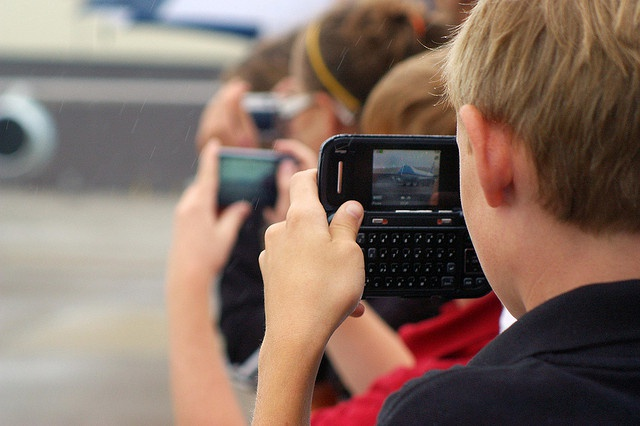Describe the objects in this image and their specific colors. I can see people in beige, black, brown, tan, and maroon tones, people in beige, tan, maroon, and gray tones, cell phone in beige, black, and gray tones, people in beige, black, maroon, and gray tones, and people in beige, gray, tan, and darkgray tones in this image. 